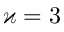Convert formula to latex. <formula><loc_0><loc_0><loc_500><loc_500>\varkappa = 3</formula> 